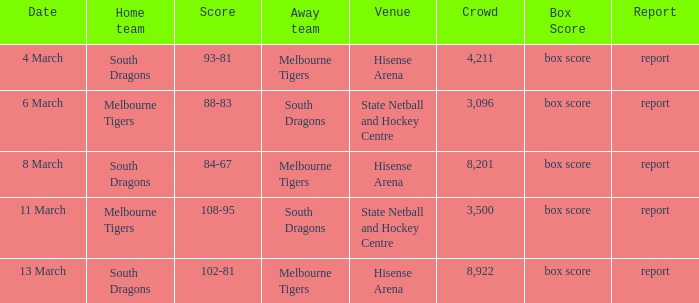Where was the location with 3,096 spectators and against the melbourne tigers? Hisense Arena, Hisense Arena, Hisense Arena. 